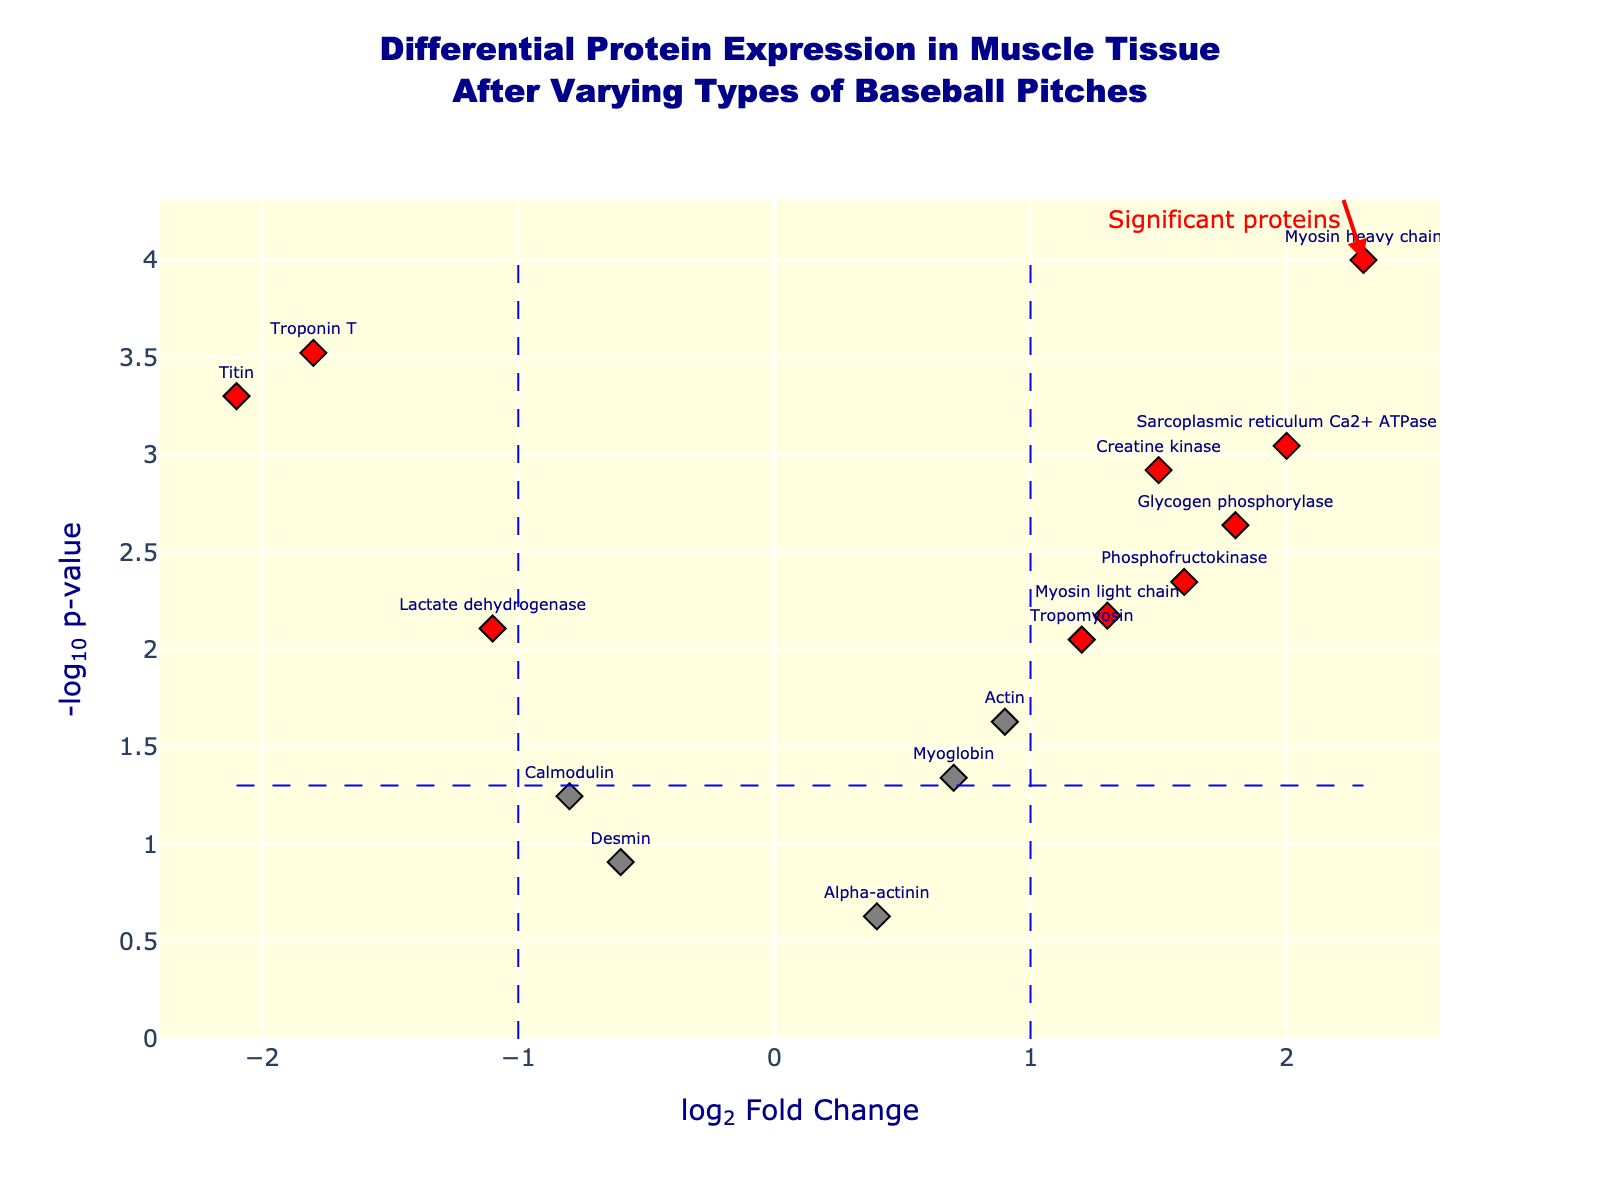What is the title of the plot? The title is displayed at the top of the plot. It reads "Differential Protein Expression in Muscle Tissue After Varying Types of Baseball Pitches".
Answer: Differential Protein Expression in Muscle Tissue After Varying Types of Baseball Pitches How many proteins are marked in red? Red color signifies proteins with significant differential expression based on the figure's threshold criteria. By counting the red points in the plot, you can determine the number of significant proteins.
Answer: 7 Which protein has the highest log2 fold change? Look at the x-axis (log2 Fold Change) and identify the protein with the highest value towards the right. The highest log2 fold change is for the "Myosin heavy chain" with a value of 2.3.
Answer: Myosin heavy chain What is the log2 fold change and p-value of the protein with the name "Titin"? Locate the data point for "Titin" in the plot. The log2 fold change for Titin is -2.1, and its p-value is 0.0005.
Answer: -2.1, 0.0005 Which protein has the lowest p-value, and what is it? The p-value is represented on the y-axis (-log10(pValue)). The higher up the point, the lower the p-value. The "Myosin heavy chain" has the highest position, thus the lowest p-value, which is 0.0001.
Answer: Myosin heavy chain, 0.0001 How many proteins have a log2 fold change greater than 1 and a p-value less than 0.05? Count the proteins to the right of the vertical threshold line at log2 fold change = 1 and below the horizontal threshold line at p-value = 0.05. These proteins are marked in red.
Answer: 4 Of the significant proteins, which one has the lowest log2 fold change? Significant proteins are marked in red. Check the log2 fold change values of these red points and identify the one with the lowest value. "Titin" has the lowest log2 fold change of -2.1.
Answer: Titin Compare the log2 fold change of "Tropomyosin" and "Myosin light chain". Which one is higher? Locate "Tropomyosin" and "Myosin light chain" on the x-axis (log2 Fold Change) and compare their values. "Myosin light chain" has a log2 fold change of 1.3, while "Tropomyosin" has a value of 1.2. Therefore, "Myosin light chain" is higher.
Answer: Myosin light chain Which proteins have a p-value higher than 0.05? These proteins will be below the horizontal line marking the threshold for significance. They include points that are gray and below a y-axis value corresponding to -log10(0.05).
Answer: Desmin, Alpha-actinin, Calmodulin 